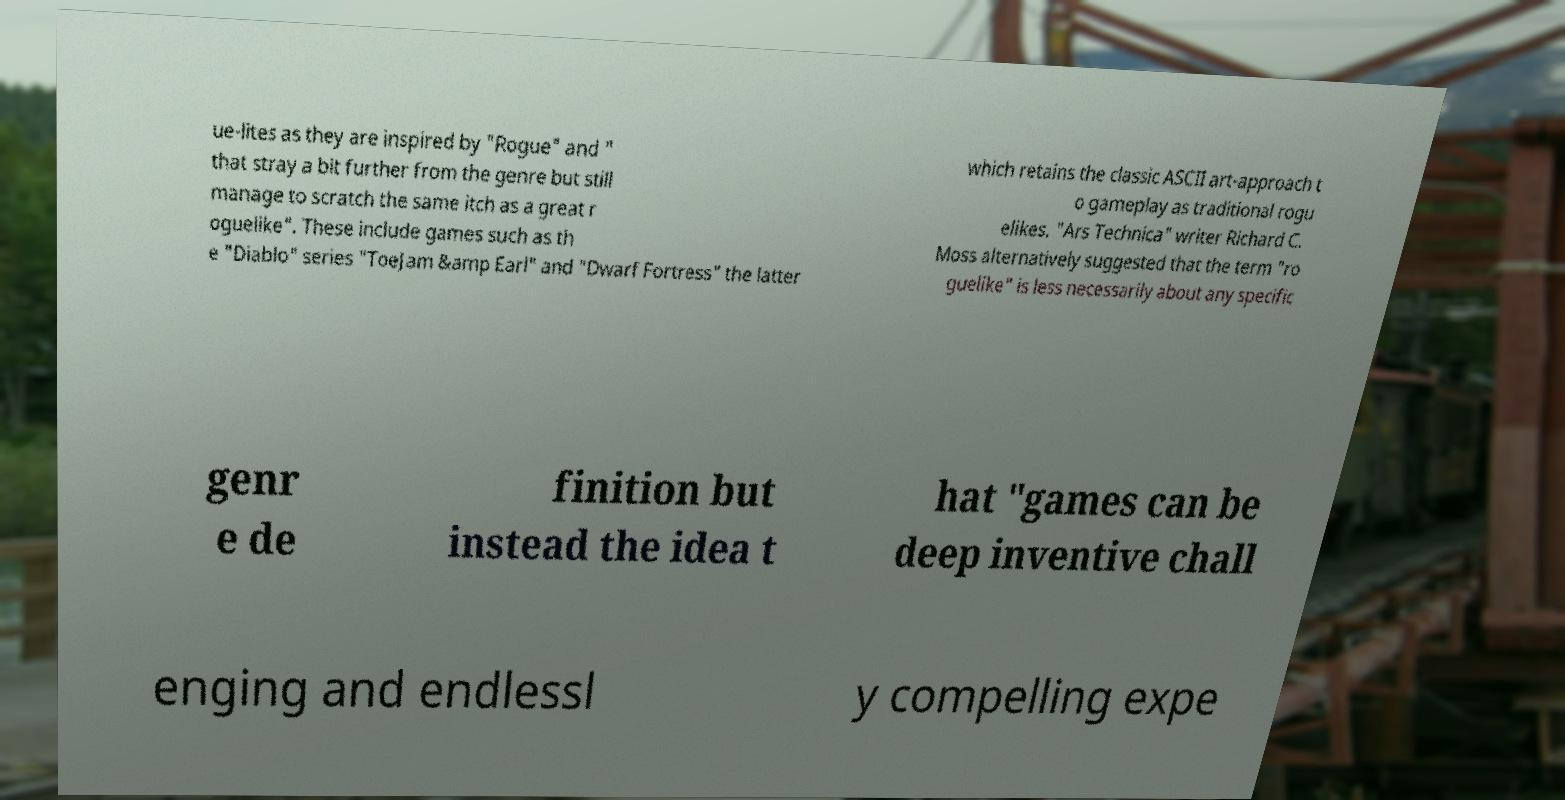Can you read and provide the text displayed in the image?This photo seems to have some interesting text. Can you extract and type it out for me? ue-lites as they are inspired by "Rogue" and " that stray a bit further from the genre but still manage to scratch the same itch as a great r oguelike". These include games such as th e "Diablo" series "ToeJam &amp Earl" and "Dwarf Fortress" the latter which retains the classic ASCII art-approach t o gameplay as traditional rogu elikes. "Ars Technica" writer Richard C. Moss alternatively suggested that the term "ro guelike" is less necessarily about any specific genr e de finition but instead the idea t hat "games can be deep inventive chall enging and endlessl y compelling expe 